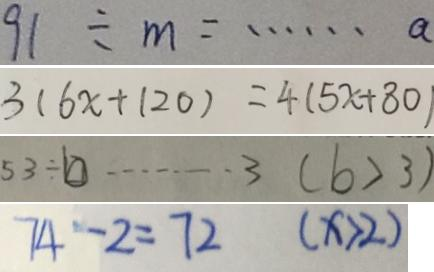<formula> <loc_0><loc_0><loc_500><loc_500>9 1 \div m = \cdots a 
 3 ( 6 x + 1 2 0 ) = 4 ( 5 x + 8 0 ) 
 5 3 \div b \cdots 3 ( b > 3 ) 
 7 4 - 2 = 7 2 ( x > 2 )</formula> 